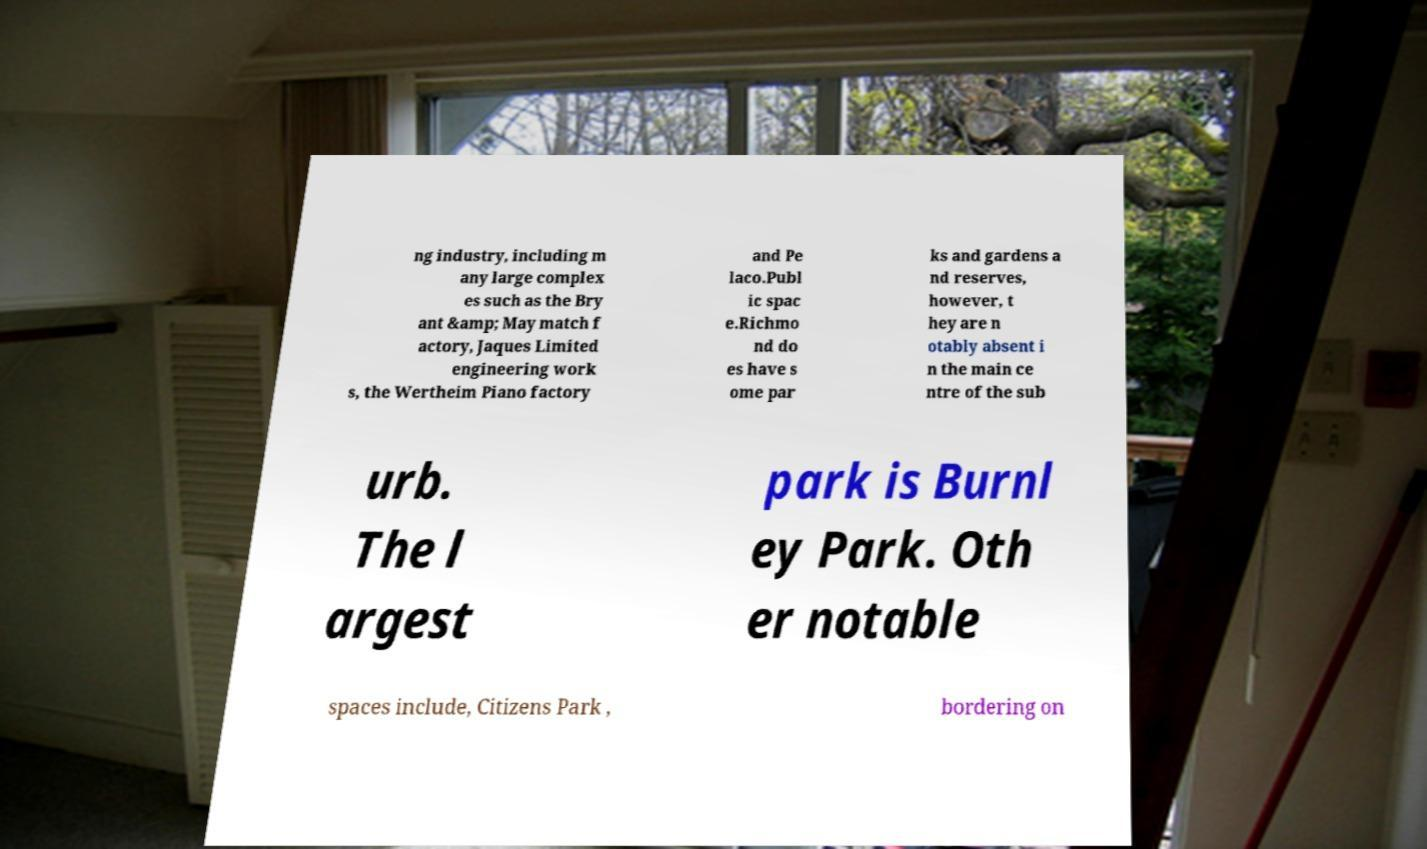Could you extract and type out the text from this image? ng industry, including m any large complex es such as the Bry ant &amp; May match f actory, Jaques Limited engineering work s, the Wertheim Piano factory and Pe laco.Publ ic spac e.Richmo nd do es have s ome par ks and gardens a nd reserves, however, t hey are n otably absent i n the main ce ntre of the sub urb. The l argest park is Burnl ey Park. Oth er notable spaces include, Citizens Park , bordering on 